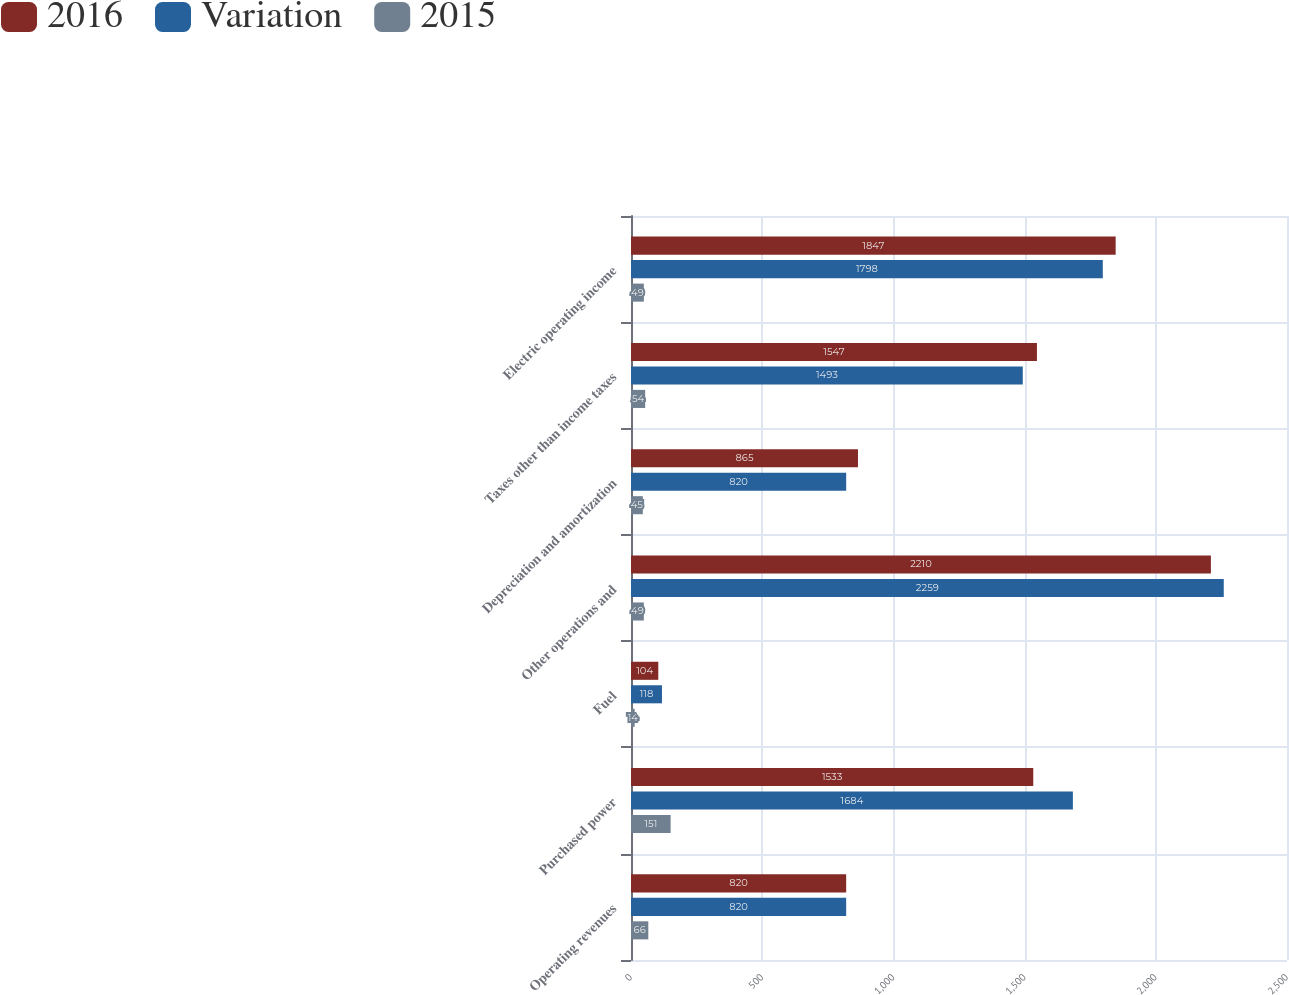<chart> <loc_0><loc_0><loc_500><loc_500><stacked_bar_chart><ecel><fcel>Operating revenues<fcel>Purchased power<fcel>Fuel<fcel>Other operations and<fcel>Depreciation and amortization<fcel>Taxes other than income taxes<fcel>Electric operating income<nl><fcel>2016<fcel>820<fcel>1533<fcel>104<fcel>2210<fcel>865<fcel>1547<fcel>1847<nl><fcel>Variation<fcel>820<fcel>1684<fcel>118<fcel>2259<fcel>820<fcel>1493<fcel>1798<nl><fcel>2015<fcel>66<fcel>151<fcel>14<fcel>49<fcel>45<fcel>54<fcel>49<nl></chart> 